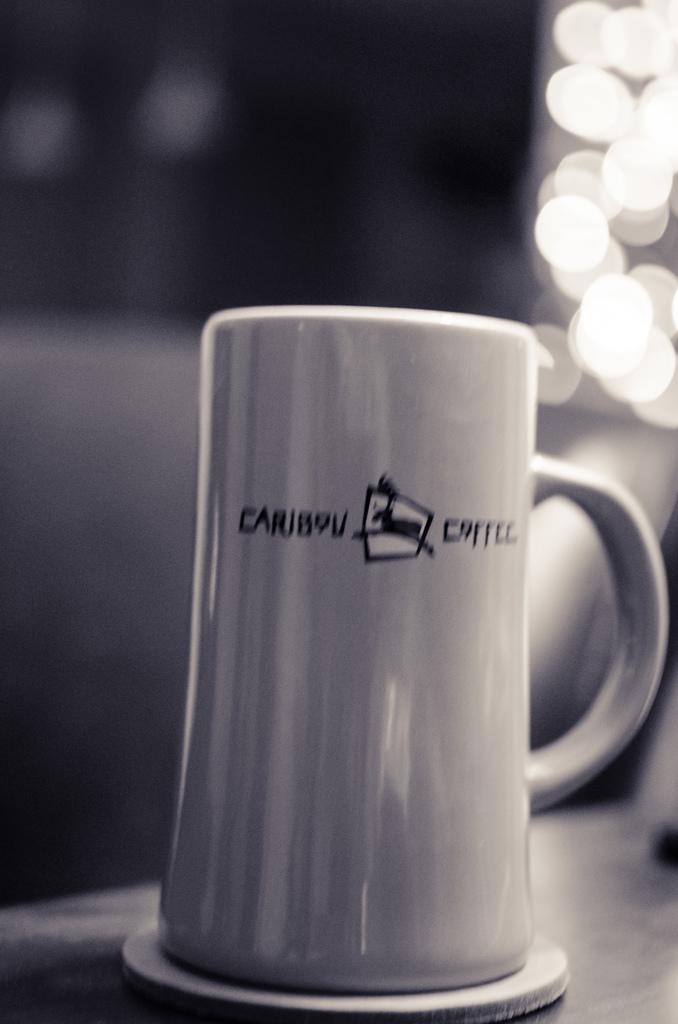<image>
Relay a brief, clear account of the picture shown. A tall white mug with the words caribou coffee written on it. 